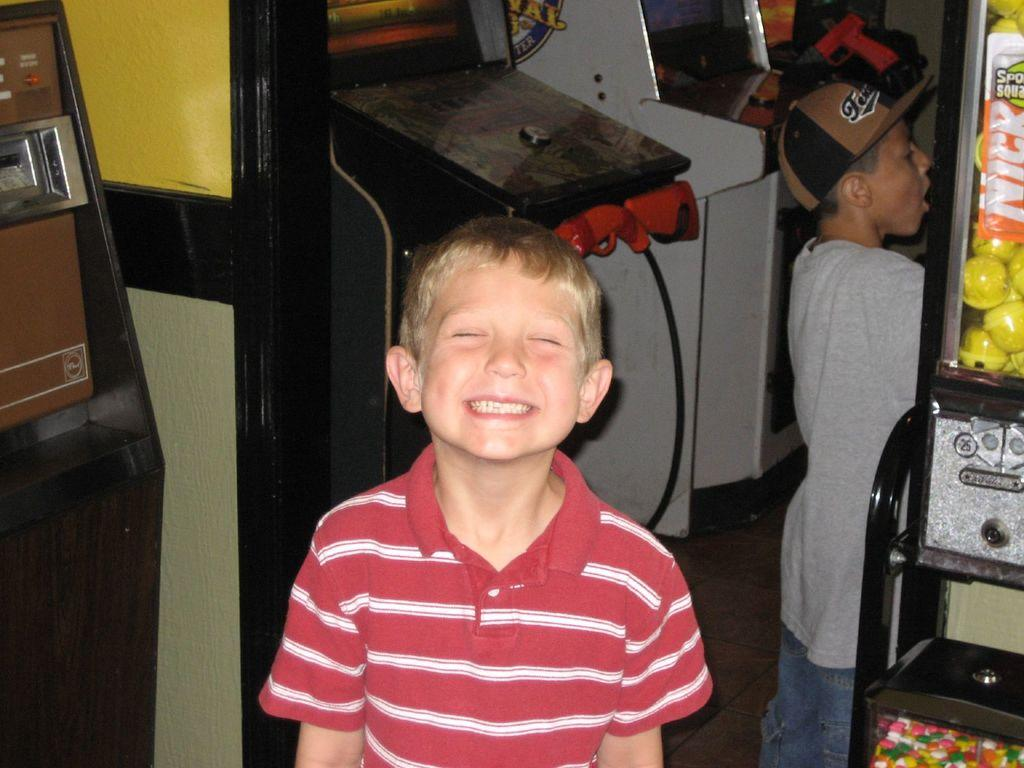What is the main subject in the foreground of the image? There is a boy standing in the foreground of the image. What can be seen behind the boy in the image? There are machines visible behind the boy. Are there any other people present in the image? Yes, there is another boy standing beside a machine on the right side of the image. What type of division is being performed by the machines in the image? There is no indication of any division being performed by the machines in the image. The machines are simply visible in the background, but their function is not specified. 